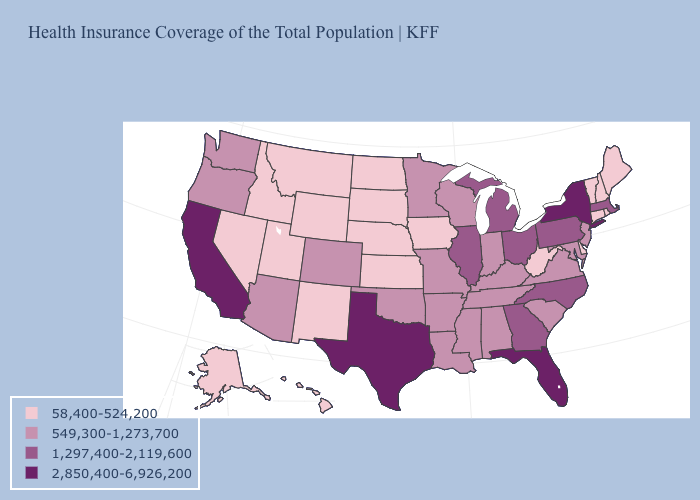What is the highest value in the USA?
Be succinct. 2,850,400-6,926,200. Which states hav the highest value in the West?
Write a very short answer. California. Name the states that have a value in the range 2,850,400-6,926,200?
Give a very brief answer. California, Florida, New York, Texas. How many symbols are there in the legend?
Write a very short answer. 4. Name the states that have a value in the range 2,850,400-6,926,200?
Give a very brief answer. California, Florida, New York, Texas. What is the lowest value in states that border Washington?
Be succinct. 58,400-524,200. What is the value of South Carolina?
Be succinct. 549,300-1,273,700. What is the highest value in the MidWest ?
Answer briefly. 1,297,400-2,119,600. Does Florida have the highest value in the South?
Give a very brief answer. Yes. What is the value of Tennessee?
Keep it brief. 549,300-1,273,700. Which states hav the highest value in the South?
Answer briefly. Florida, Texas. Does Utah have the lowest value in the USA?
Be succinct. Yes. Does the map have missing data?
Give a very brief answer. No. Does South Dakota have the highest value in the USA?
Be succinct. No. What is the lowest value in the USA?
Keep it brief. 58,400-524,200. 